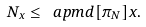Convert formula to latex. <formula><loc_0><loc_0><loc_500><loc_500>N _ { x } \leq \ a p m d [ \pi _ { N } ] { x } .</formula> 